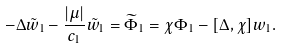<formula> <loc_0><loc_0><loc_500><loc_500>- \Delta \tilde { w } _ { 1 } - \frac { | \mu | } { c _ { 1 } } \tilde { w } _ { 1 } = \widetilde { \Phi } _ { 1 } = \chi \Phi _ { 1 } - [ \Delta , \chi ] w _ { 1 } .</formula> 